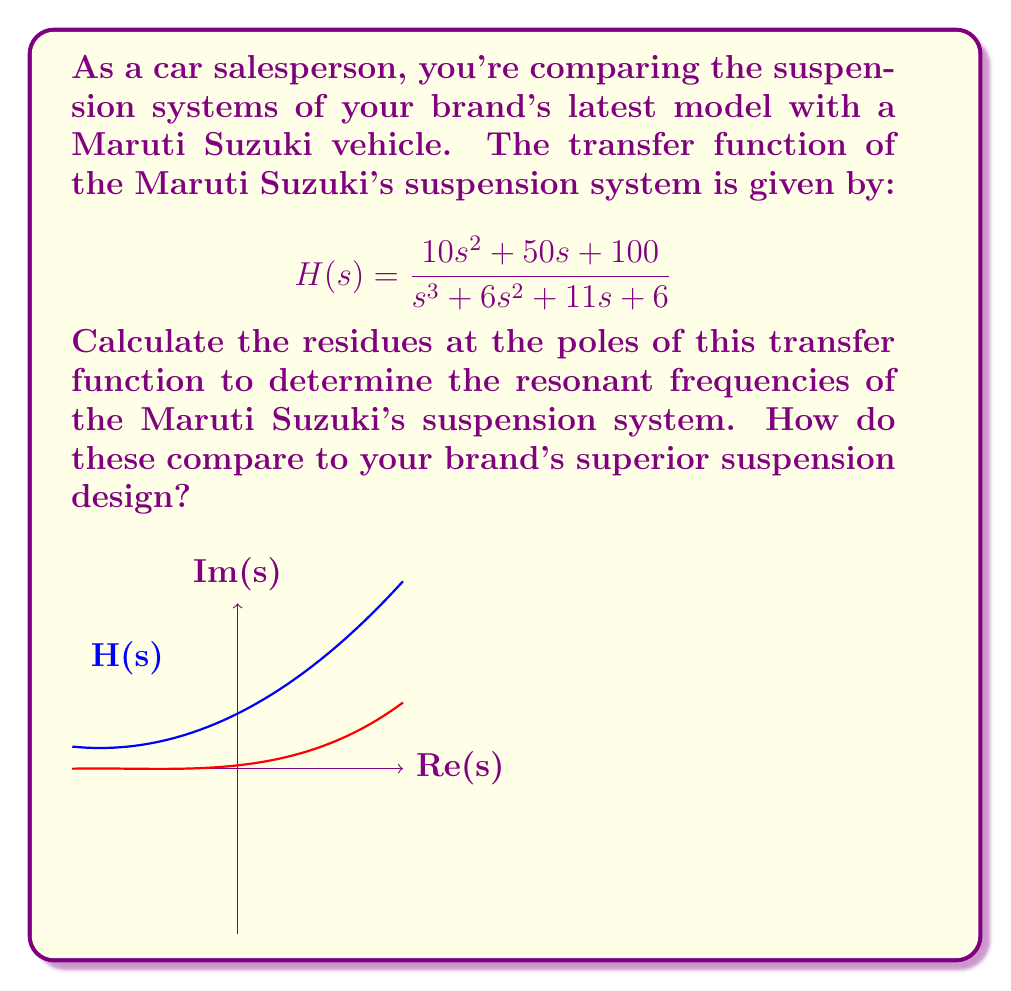Could you help me with this problem? To solve this problem, we'll follow these steps:

1) First, we need to find the poles of the transfer function. These are the roots of the denominator polynomial:

   $$s^3 + 6s^2 + 11s + 6 = 0$$

   The roots are $s_1 = -1$, $s_2 = -2$, and $s_3 = -3$.

2) Now, we'll calculate the residue at each pole using the formula:

   $$\text{Res}(H, s_i) = \lim_{s \to s_i} (s - s_i) H(s)$$

3) For $s_1 = -1$:
   
   $$\begin{align*}
   \text{Res}(H, -1) &= \lim_{s \to -1} (s + 1) \frac{10s^2 + 50s + 100}{s^3 + 6s^2 + 11s + 6} \\
   &= \frac{10(-1)^2 + 50(-1) + 100}{3(-1)^2 + 2(-1) + 1} = \frac{60}{4} = 15
   \end{align*}$$

4) For $s_2 = -2$:

   $$\begin{align*}
   \text{Res}(H, -2) &= \lim_{s \to -2} (s + 2) \frac{10s^2 + 50s + 100}{s^3 + 6s^2 + 11s + 6} \\
   &= \frac{10(-2)^2 + 50(-2) + 100}{3(-2)^2 + 2(-2) - 2} = \frac{40}{-2} = -20
   \end{align*}$$

5) For $s_3 = -3$:

   $$\begin{align*}
   \text{Res}(H, -3) &= \lim_{s \to -3} (s + 3) \frac{10s^2 + 50s + 100}{s^3 + 6s^2 + 11s + 6} \\
   &= \frac{10(-3)^2 + 50(-3) + 100}{3(-3)^2 + 2(-3) - 5} = \frac{10}{1} = 10
   \end{align*}$$

6) The resonant frequencies are related to the imaginary parts of the poles. In this case, all poles are real, indicating that the system is overdamped and doesn't have clear resonant frequencies.

7) The magnitudes of the residues (15, 20, and 10) indicate the relative strengths of the system's response at the corresponding pole frequencies.
Answer: Residues: 15, -20, 10. No clear resonant frequencies due to overdamped system. 